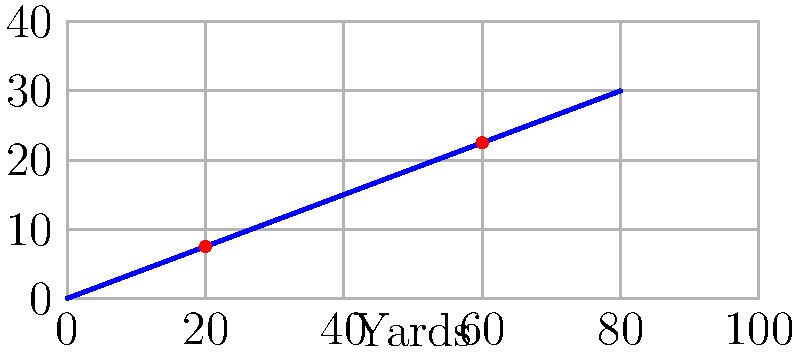In a crucial play during the Super Bowl, the star quarterback makes an impressive throw. The trajectory of the football can be represented on a coordinate plane, where the x-axis shows the distance in yards and the y-axis shows the height in feet. If the ball passes through the points (20, 7.5) and (60, 22.5), what is the slope of the line representing the ball's trajectory? To find the slope of the line representing the quarterback's throw, we can use the slope formula:

$$ m = \frac{y_2 - y_1}{x_2 - x_1} $$

Where $(x_1, y_1)$ and $(x_2, y_2)$ are two points on the line.

Given:
- Point 1: $(x_1, y_1) = (20, 7.5)$
- Point 2: $(x_2, y_2) = (60, 22.5)$

Let's substitute these values into the slope formula:

$$ m = \frac{22.5 - 7.5}{60 - 20} $$

$$ m = \frac{15}{40} $$

Simplifying the fraction:

$$ m = \frac{3}{8} = 0.375 $$

This means that for every 8 yards the ball travels horizontally, it gains 3 feet in height.
Answer: $\frac{3}{8}$ or $0.375$ 